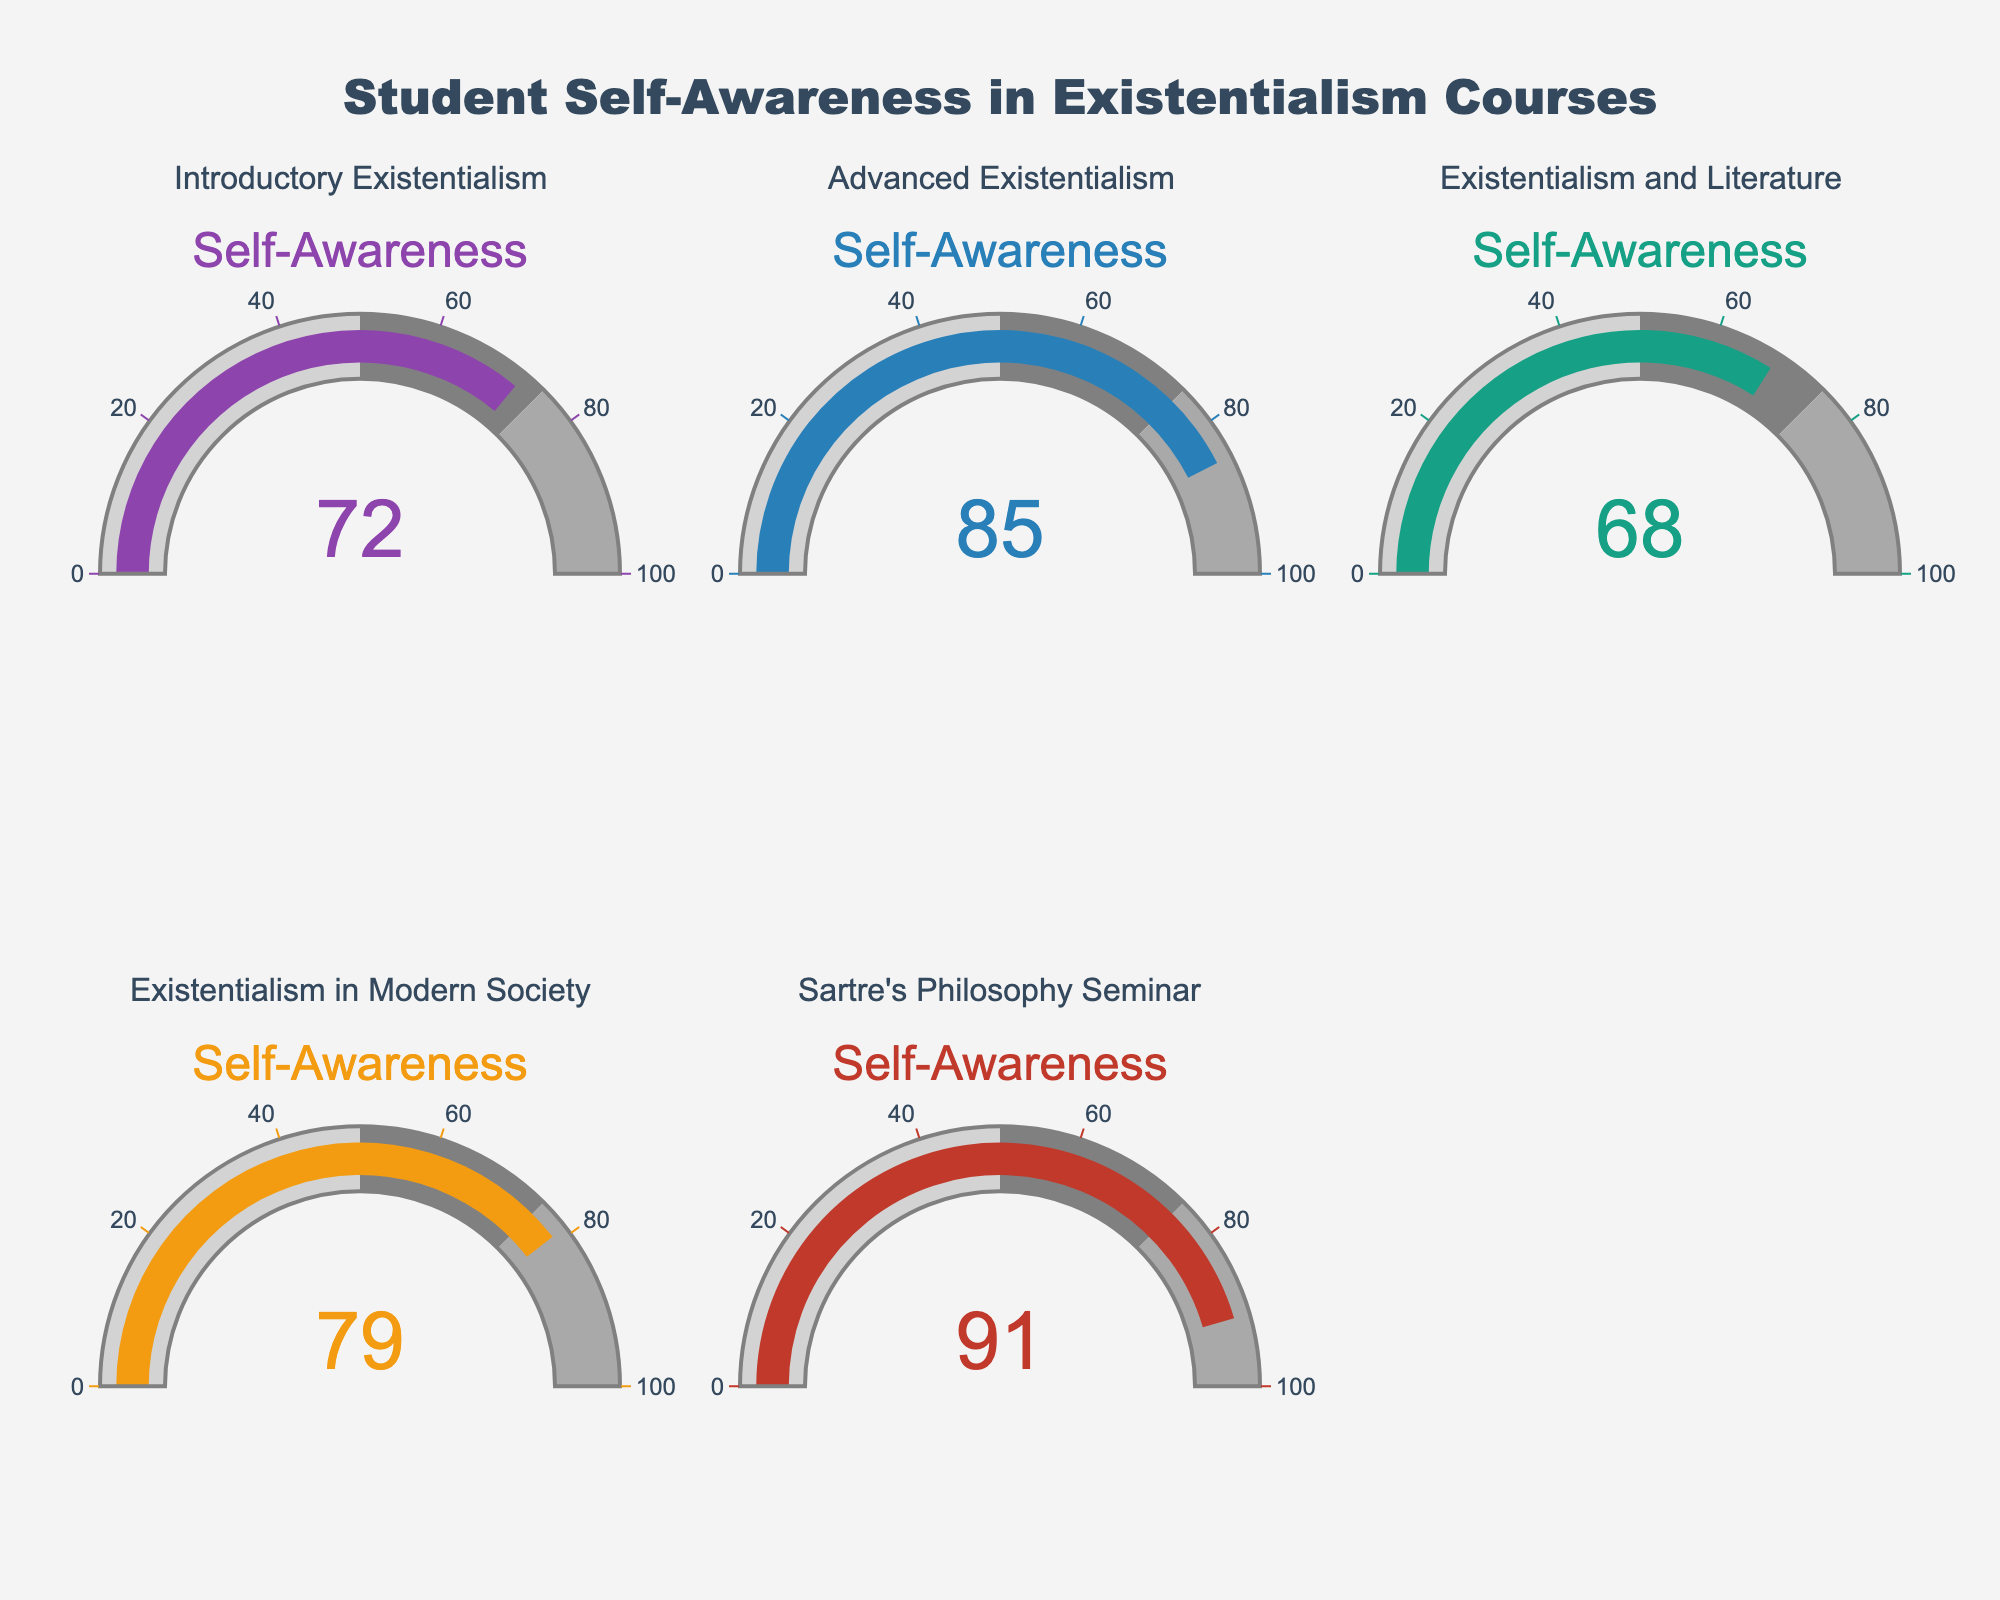What is the highest percentage of students reporting increased self-awareness after an existentialism course? The gauge corresponding to "Sartre's Philosophy Seminar" shows the highest value, which is 91%.
Answer: 91 Which course has the lowest percentage of students reporting increased self-awareness? "Existentialism and Literature" has the lowest percentage as indicated by the gauge showing 68%.
Answer: 68 What’s the difference in self-awareness percentage between "Introductory Existentialism" and "Advanced Existentialism"? The gauge for "Introductory Existentialism" shows 72%, whereas the gauge for "Advanced Existentialism" shows 85%. The difference is 85 - 72.
Answer: 13 How many courses have more than 75% of students reporting increased self-awareness? The gauges for "Advanced Existentialism", "Existentialism in Modern Society", and "Sartre's Philosophy Seminar" show values greater than 75%. That makes three courses in total.
Answer: 3 What is the average percentage of students reporting increased self-awareness across all courses? Add the percentages of all courses: 72 + 85 + 68 + 79 + 91 = 395. Then divide by the number of courses: 395 / 5.
Answer: 79 Which courses have percentages between 70% and 80%? The gauges for "Introductory Existentialism" (72%) and "Existentialism in Modern Society" (79%) show values within this range.
Answer: "Introductory Existentialism" and "Existentialism in Modern Society" What is the combined percentage of "Existentialism and Literature" and "Sartre's Philosophy Seminar"? Add the percentages from the gauges of both courses: 68 + 91.
Answer: 159 How does the self-awareness percentage for "Existentialism in Modern Society" compare to the overall average? The percentage for "Existentialism in Modern Society" is 79%. The overall average percentage is also 79%. Therefore, they are equal.
Answer: equal 